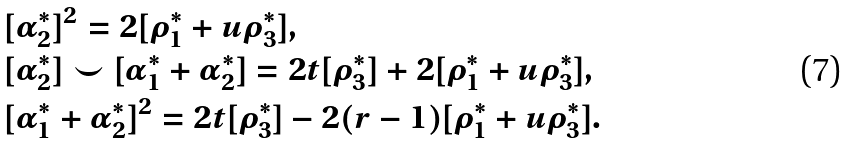Convert formula to latex. <formula><loc_0><loc_0><loc_500><loc_500>& [ \alpha _ { 2 } ^ { * } ] ^ { 2 } = 2 [ \rho _ { 1 } ^ { * } + u \rho _ { 3 } ^ { * } ] , \\ & [ \alpha _ { 2 } ^ { * } ] \smile [ \alpha _ { 1 } ^ { * } + \alpha _ { 2 } ^ { * } ] = 2 t [ \rho _ { 3 } ^ { * } ] + 2 [ \rho _ { 1 } ^ { * } + u \rho _ { 3 } ^ { * } ] , \\ & [ \alpha _ { 1 } ^ { * } + \alpha _ { 2 } ^ { * } ] ^ { 2 } = 2 t [ \rho _ { 3 } ^ { * } ] - 2 ( r - 1 ) [ \rho _ { 1 } ^ { * } + u \rho _ { 3 } ^ { * } ] .</formula> 